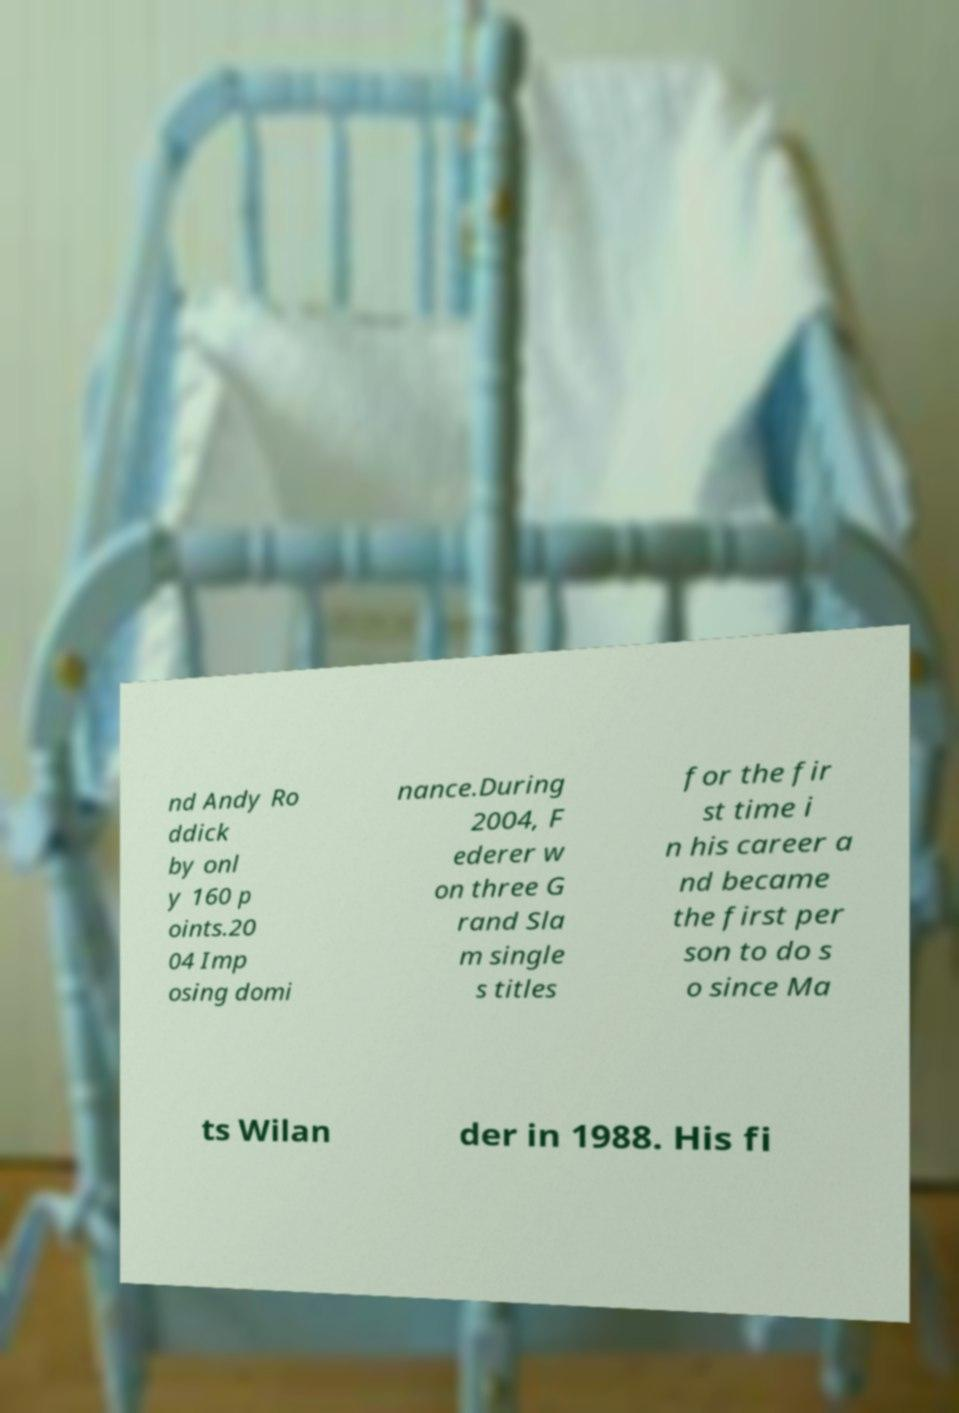I need the written content from this picture converted into text. Can you do that? nd Andy Ro ddick by onl y 160 p oints.20 04 Imp osing domi nance.During 2004, F ederer w on three G rand Sla m single s titles for the fir st time i n his career a nd became the first per son to do s o since Ma ts Wilan der in 1988. His fi 